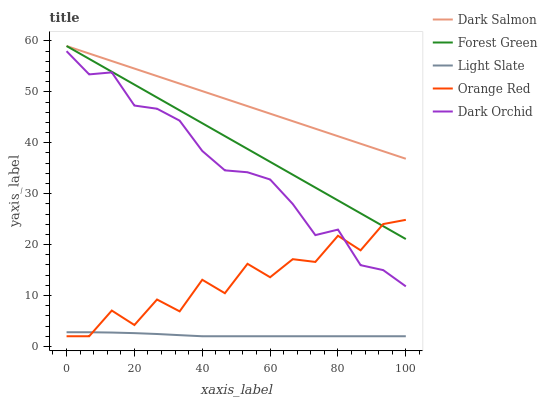Does Light Slate have the minimum area under the curve?
Answer yes or no. Yes. Does Dark Salmon have the maximum area under the curve?
Answer yes or no. Yes. Does Forest Green have the minimum area under the curve?
Answer yes or no. No. Does Forest Green have the maximum area under the curve?
Answer yes or no. No. Is Dark Salmon the smoothest?
Answer yes or no. Yes. Is Orange Red the roughest?
Answer yes or no. Yes. Is Forest Green the smoothest?
Answer yes or no. No. Is Forest Green the roughest?
Answer yes or no. No. Does Light Slate have the lowest value?
Answer yes or no. Yes. Does Forest Green have the lowest value?
Answer yes or no. No. Does Dark Salmon have the highest value?
Answer yes or no. Yes. Does Dark Orchid have the highest value?
Answer yes or no. No. Is Light Slate less than Dark Orchid?
Answer yes or no. Yes. Is Dark Salmon greater than Orange Red?
Answer yes or no. Yes. Does Forest Green intersect Dark Salmon?
Answer yes or no. Yes. Is Forest Green less than Dark Salmon?
Answer yes or no. No. Is Forest Green greater than Dark Salmon?
Answer yes or no. No. Does Light Slate intersect Dark Orchid?
Answer yes or no. No. 